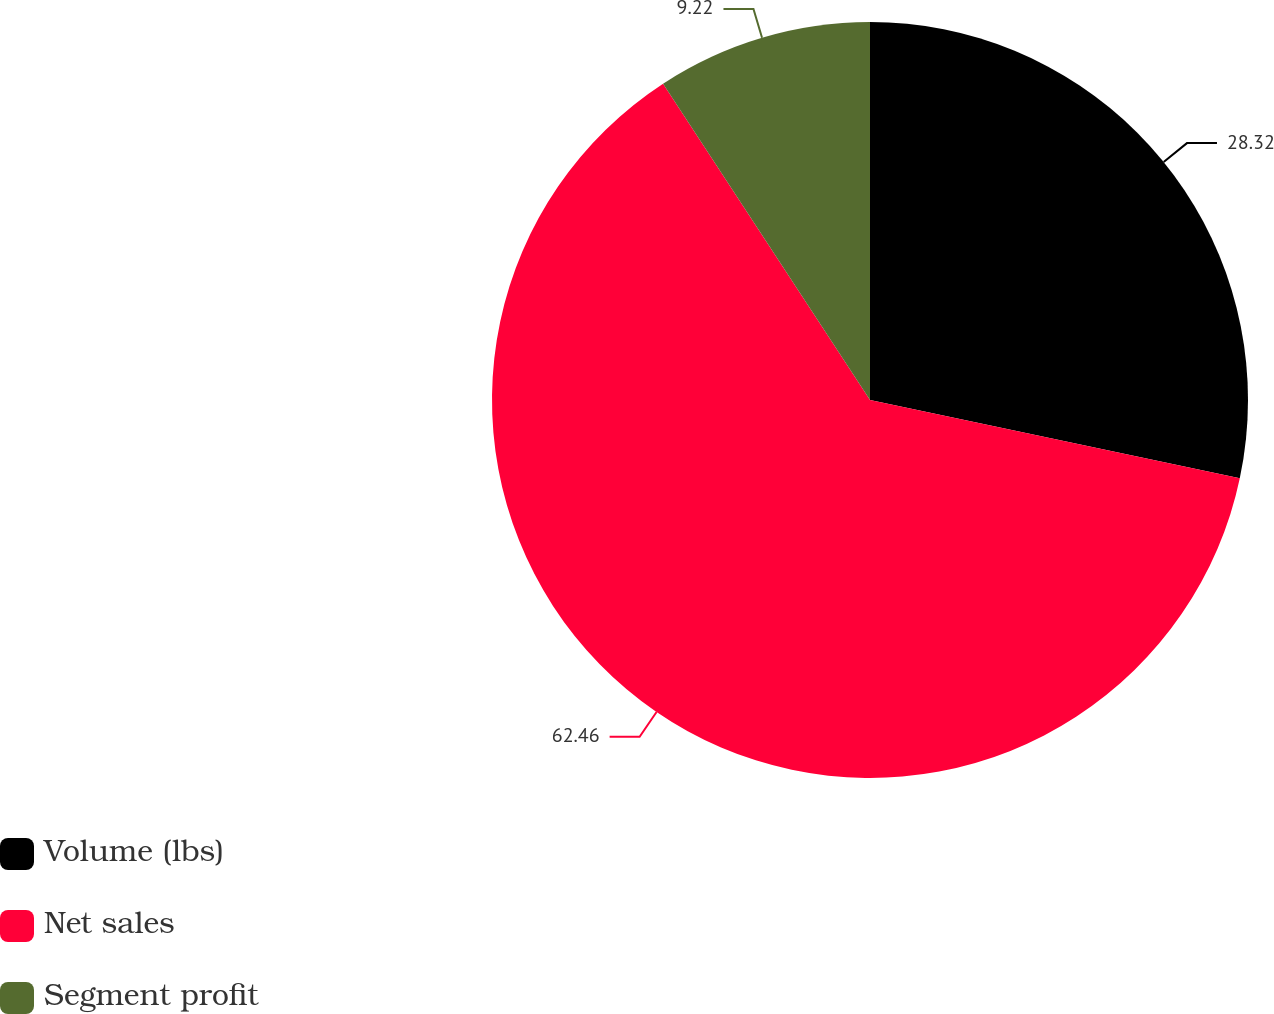<chart> <loc_0><loc_0><loc_500><loc_500><pie_chart><fcel>Volume (lbs)<fcel>Net sales<fcel>Segment profit<nl><fcel>28.32%<fcel>62.46%<fcel>9.22%<nl></chart> 